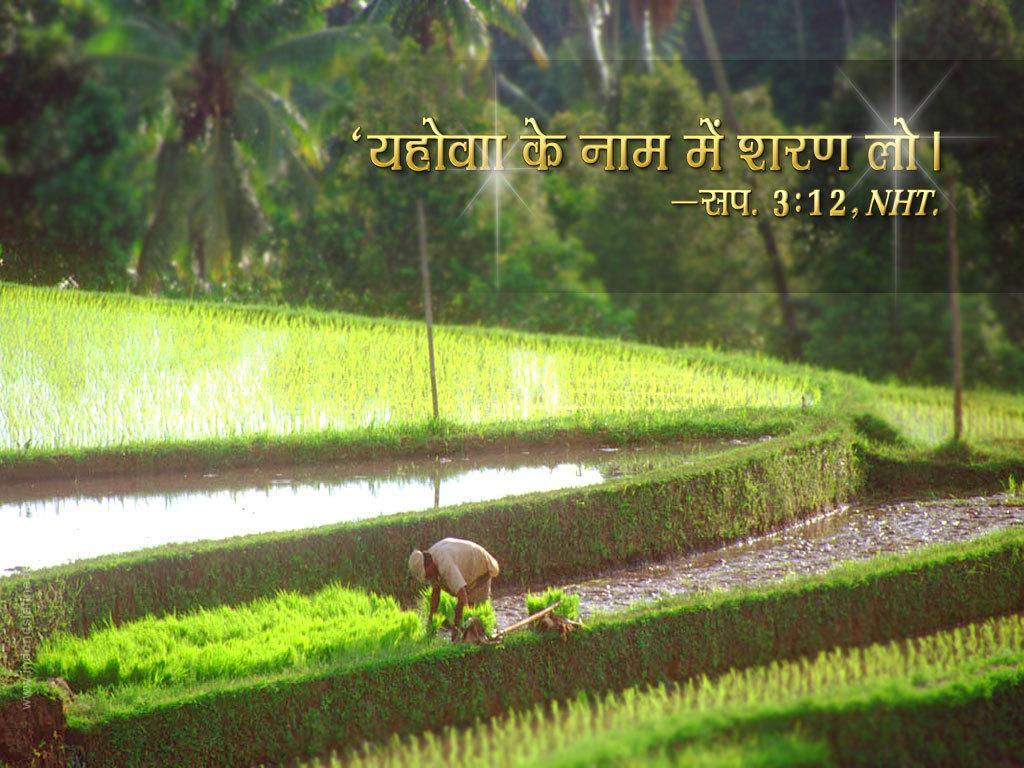Please provide a concise description of this image. This image consists of fields. There is water in the middle. There is a person at the bottom. There are trees at the top. There is something written at the top. 